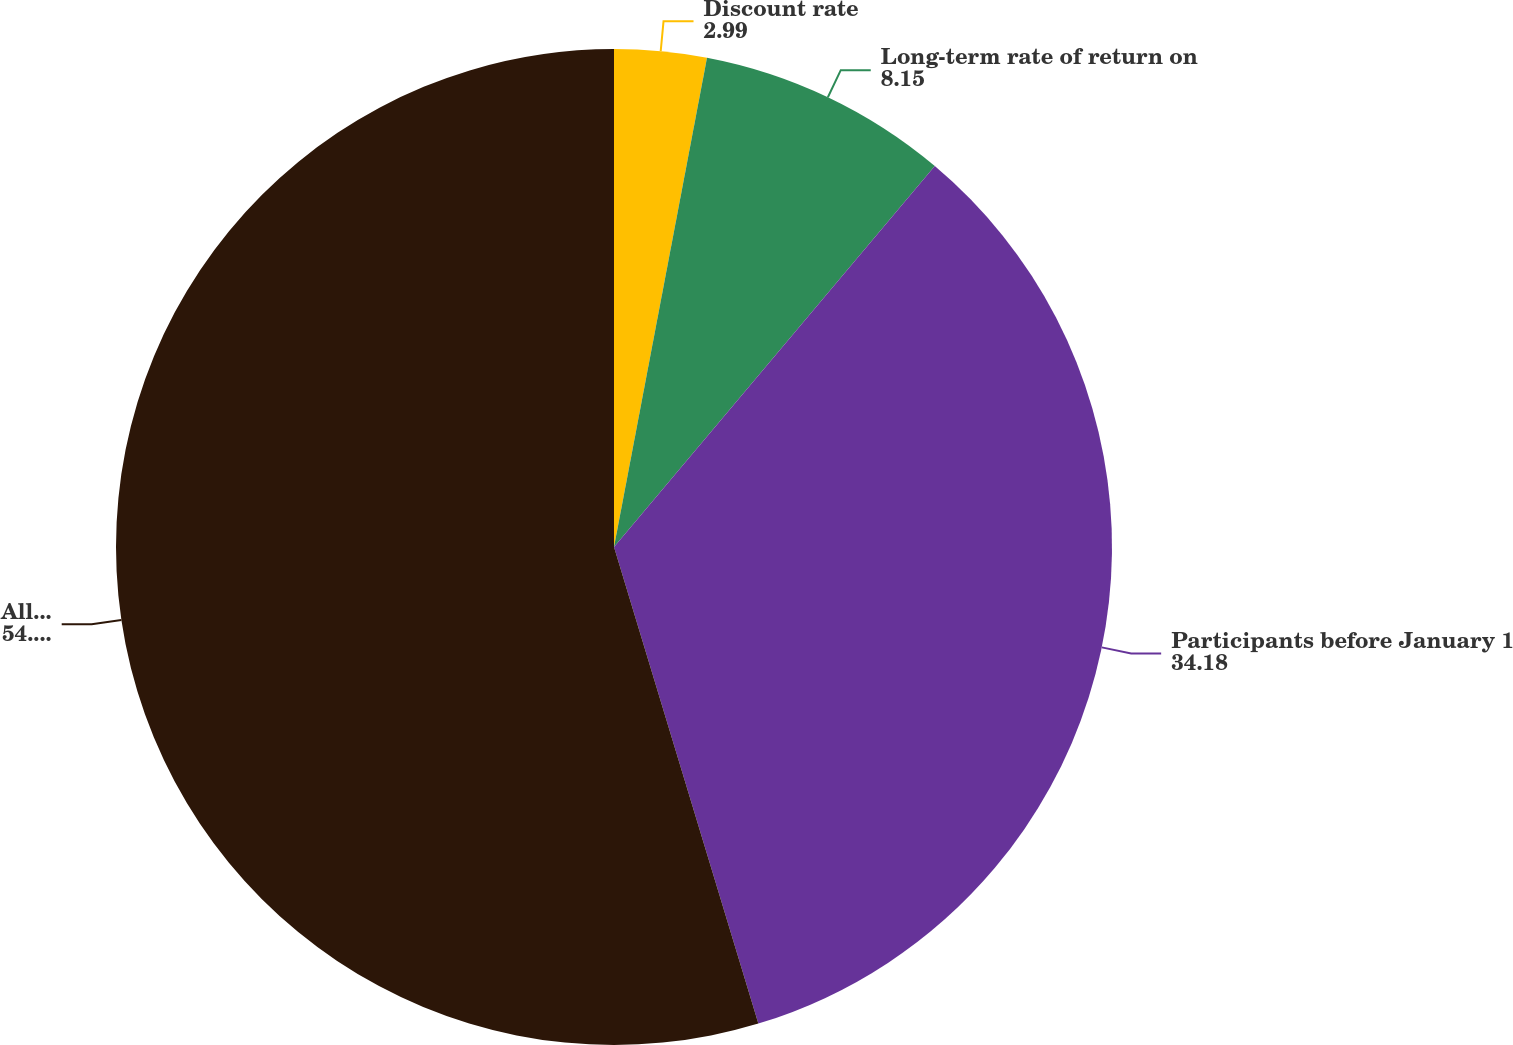<chart> <loc_0><loc_0><loc_500><loc_500><pie_chart><fcel>Discount rate<fcel>Long-term rate of return on<fcel>Participants before January 1<fcel>All other participants<nl><fcel>2.99%<fcel>8.15%<fcel>34.18%<fcel>54.68%<nl></chart> 